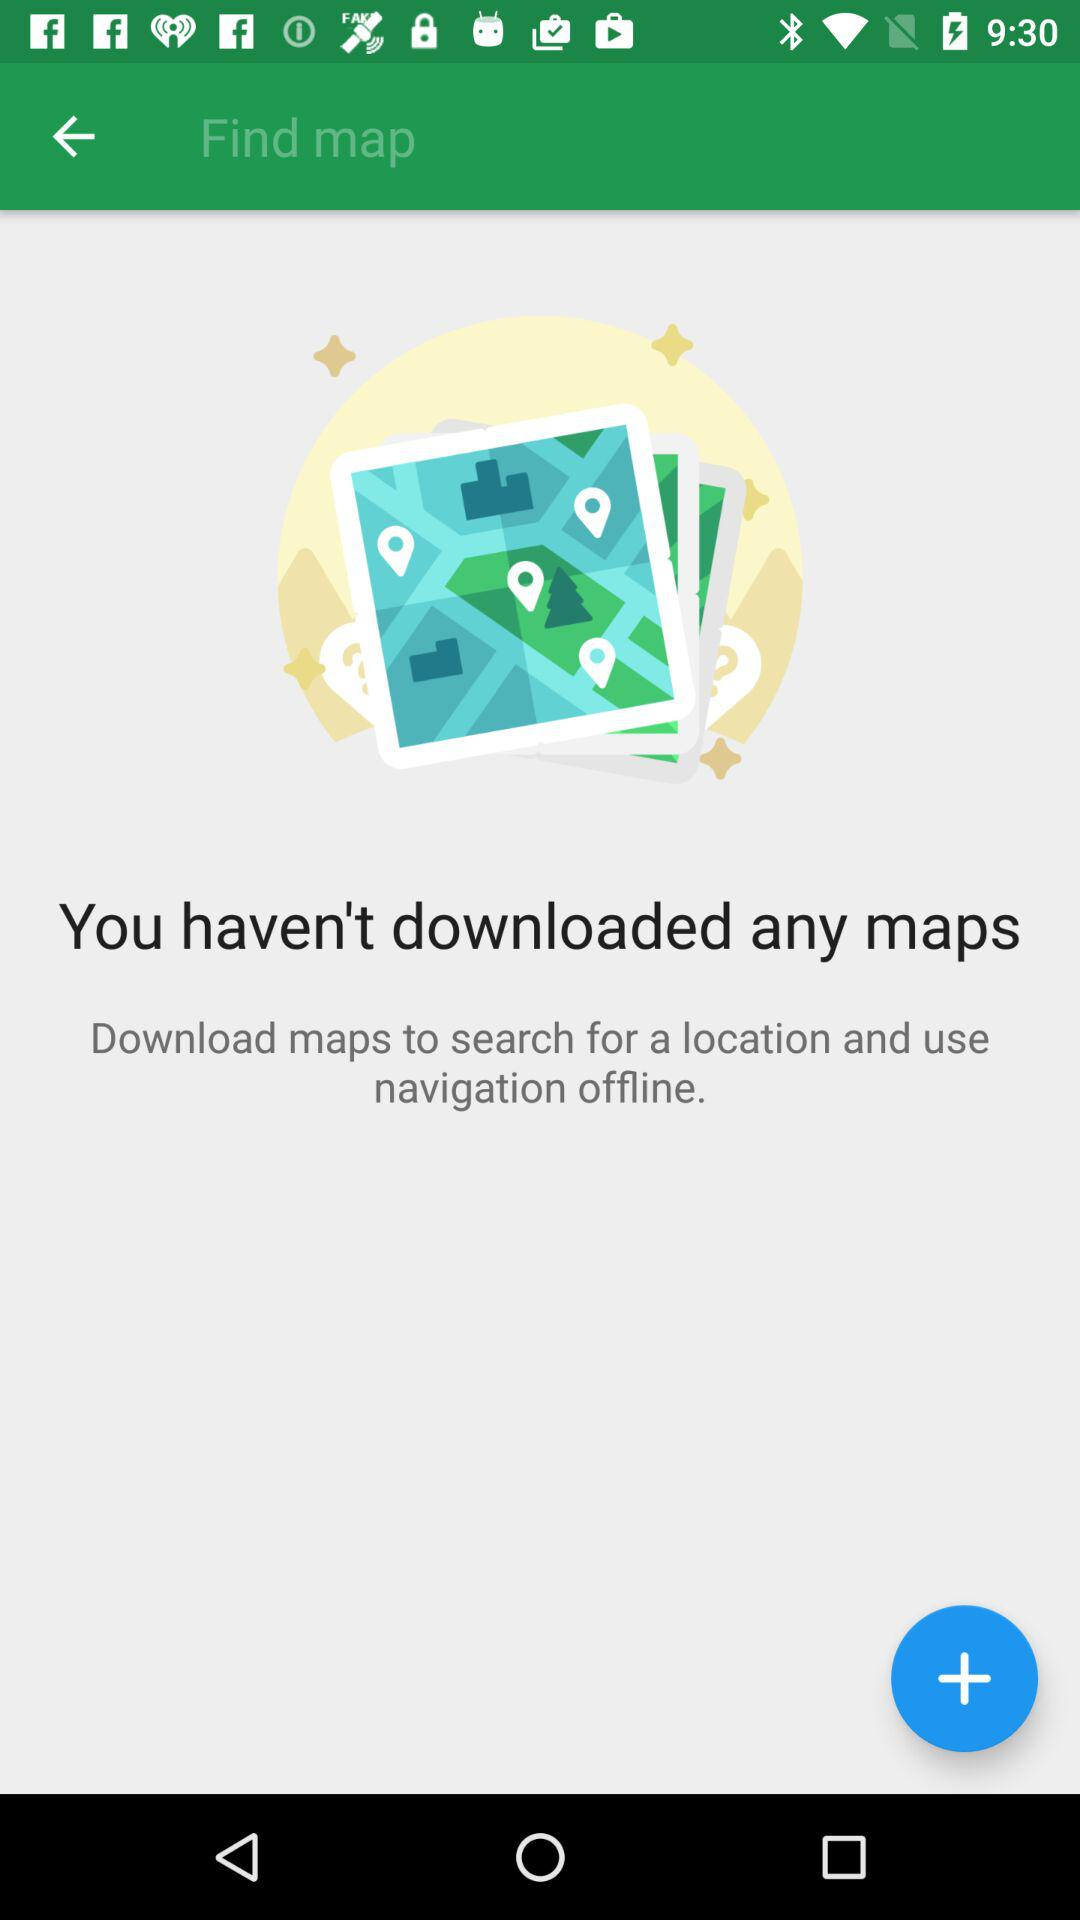How many maps have been downloaded?
Answer the question using a single word or phrase. 0 